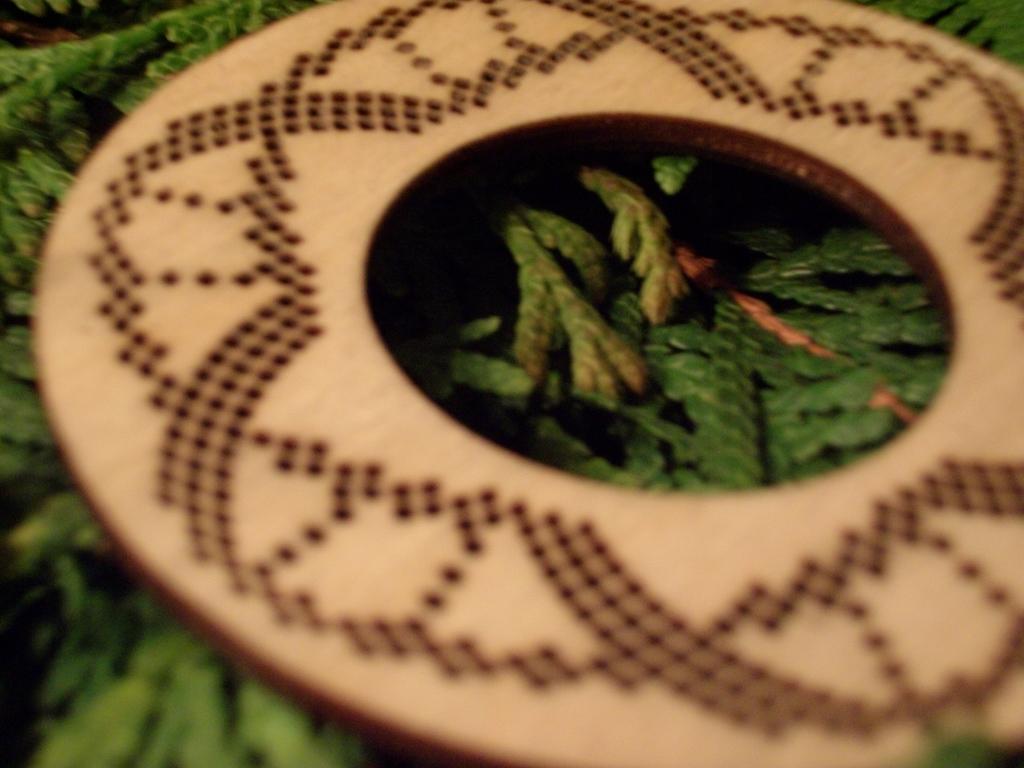How would you summarize this image in a sentence or two? In this image we can see a wooden disk placed on some leaves. 